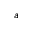Convert formula to latex. <formula><loc_0><loc_0><loc_500><loc_500>a</formula> 